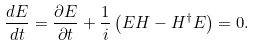Convert formula to latex. <formula><loc_0><loc_0><loc_500><loc_500>\frac { d E } { d t } = \frac { \partial E } { \partial t } + \frac { 1 } { i } \left ( E H - H ^ { \dagger } E \right ) = 0 .</formula> 